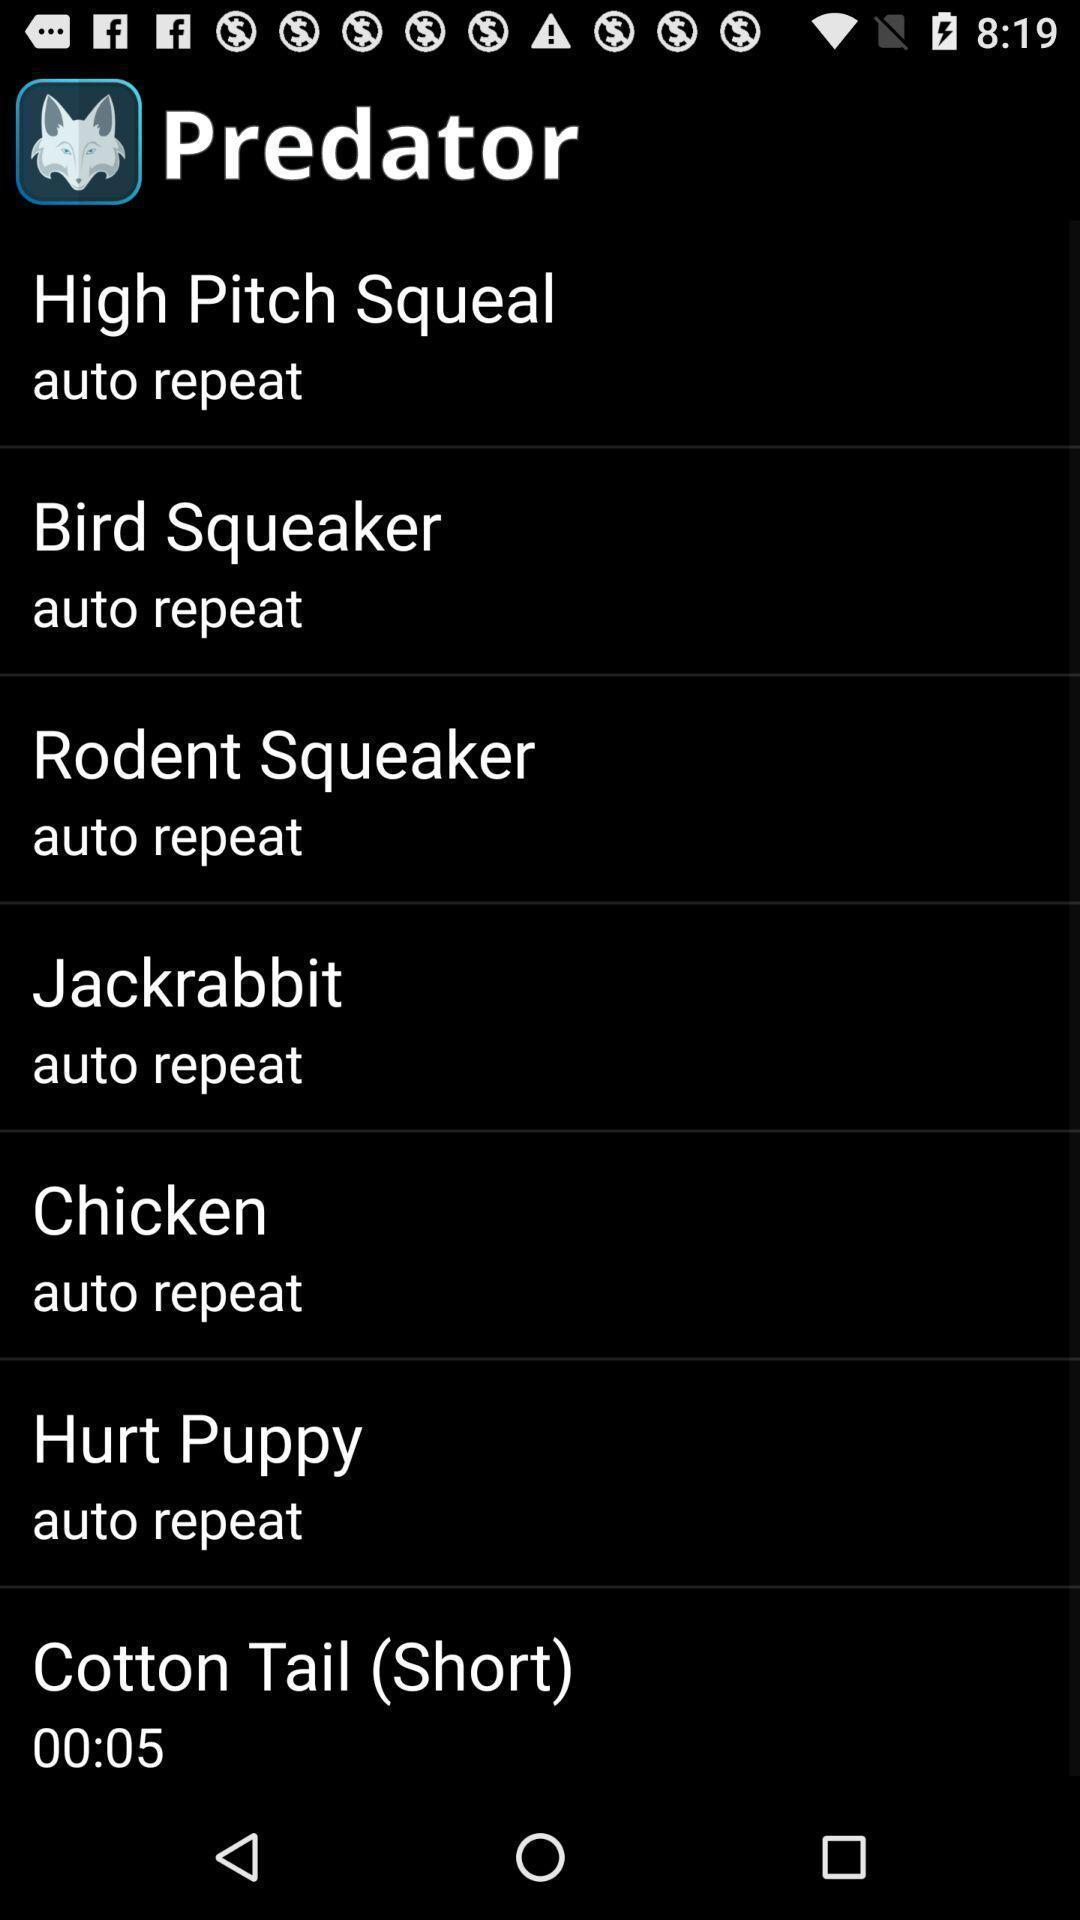Provide a detailed account of this screenshot. Screen displaying different sounds of animals. 